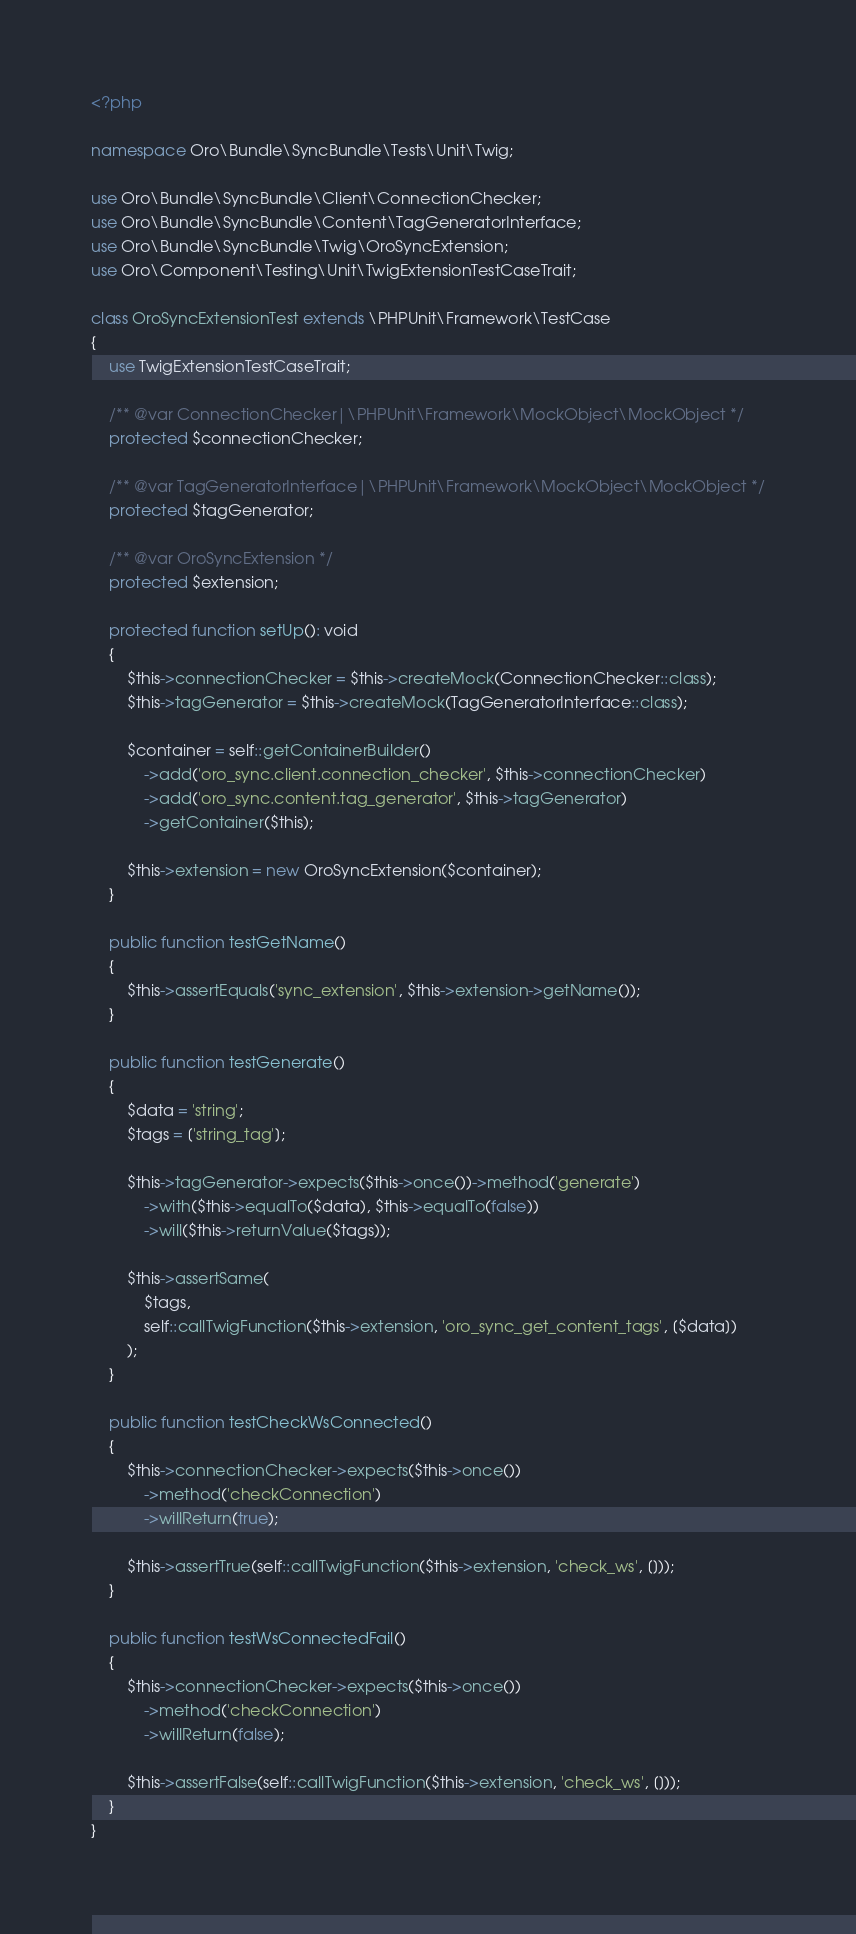<code> <loc_0><loc_0><loc_500><loc_500><_PHP_><?php

namespace Oro\Bundle\SyncBundle\Tests\Unit\Twig;

use Oro\Bundle\SyncBundle\Client\ConnectionChecker;
use Oro\Bundle\SyncBundle\Content\TagGeneratorInterface;
use Oro\Bundle\SyncBundle\Twig\OroSyncExtension;
use Oro\Component\Testing\Unit\TwigExtensionTestCaseTrait;

class OroSyncExtensionTest extends \PHPUnit\Framework\TestCase
{
    use TwigExtensionTestCaseTrait;

    /** @var ConnectionChecker|\PHPUnit\Framework\MockObject\MockObject */
    protected $connectionChecker;

    /** @var TagGeneratorInterface|\PHPUnit\Framework\MockObject\MockObject */
    protected $tagGenerator;

    /** @var OroSyncExtension */
    protected $extension;

    protected function setUp(): void
    {
        $this->connectionChecker = $this->createMock(ConnectionChecker::class);
        $this->tagGenerator = $this->createMock(TagGeneratorInterface::class);

        $container = self::getContainerBuilder()
            ->add('oro_sync.client.connection_checker', $this->connectionChecker)
            ->add('oro_sync.content.tag_generator', $this->tagGenerator)
            ->getContainer($this);

        $this->extension = new OroSyncExtension($container);
    }

    public function testGetName()
    {
        $this->assertEquals('sync_extension', $this->extension->getName());
    }

    public function testGenerate()
    {
        $data = 'string';
        $tags = ['string_tag'];

        $this->tagGenerator->expects($this->once())->method('generate')
            ->with($this->equalTo($data), $this->equalTo(false))
            ->will($this->returnValue($tags));

        $this->assertSame(
            $tags,
            self::callTwigFunction($this->extension, 'oro_sync_get_content_tags', [$data])
        );
    }

    public function testCheckWsConnected()
    {
        $this->connectionChecker->expects($this->once())
            ->method('checkConnection')
            ->willReturn(true);

        $this->assertTrue(self::callTwigFunction($this->extension, 'check_ws', []));
    }

    public function testWsConnectedFail()
    {
        $this->connectionChecker->expects($this->once())
            ->method('checkConnection')
            ->willReturn(false);

        $this->assertFalse(self::callTwigFunction($this->extension, 'check_ws', []));
    }
}
</code> 